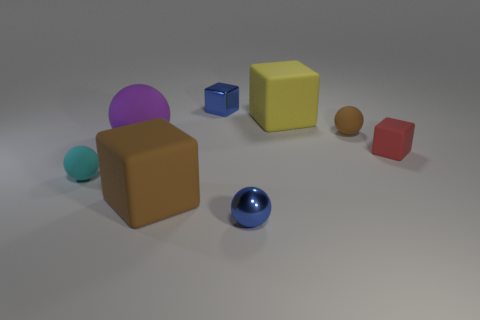Subtract all large yellow cubes. How many cubes are left? 3 Subtract all brown blocks. How many blocks are left? 3 Subtract 3 blocks. How many blocks are left? 1 Add 2 blue metal balls. How many objects exist? 10 Subtract 0 gray spheres. How many objects are left? 8 Subtract all green cubes. Subtract all yellow balls. How many cubes are left? 4 Subtract all cyan blocks. How many red spheres are left? 0 Subtract all purple matte spheres. Subtract all purple rubber balls. How many objects are left? 6 Add 6 brown matte cubes. How many brown matte cubes are left? 7 Add 5 small matte objects. How many small matte objects exist? 8 